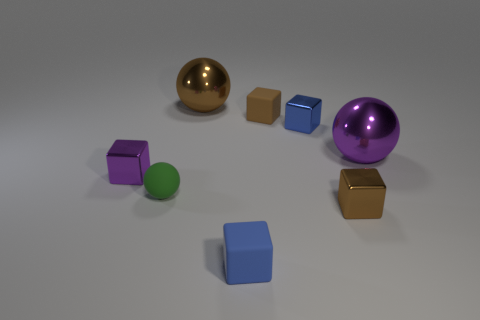Can you describe the colors and shapes of the objects in the image? Certainly! There are seven objects in various colors and shapes. Starting from the left, there is a purple cube, a green sphere, a gold sphere, a brown cube, a blue cube, a large purple sphere, and another brown cube. 